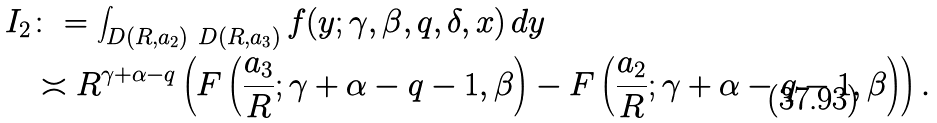<formula> <loc_0><loc_0><loc_500><loc_500>I _ { 2 } & \colon = \int _ { D ( R , a _ { 2 } ) \ D ( R , a _ { 3 } ) } f ( y ; \gamma , \beta , q , \delta , x ) \, d y \\ & \asymp R ^ { \gamma + \alpha - q } \left ( F \left ( \frac { a _ { 3 } } { R } ; \gamma + \alpha - q - 1 , \beta \right ) - F \left ( \frac { a _ { 2 } } { R } ; \gamma + \alpha - q - 1 , \beta \right ) \right ) .</formula> 